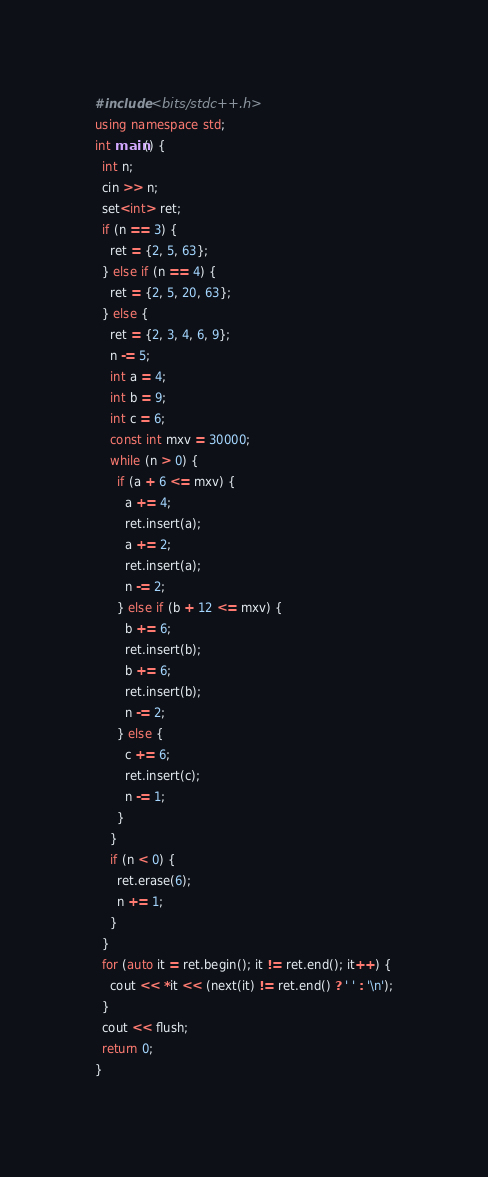Convert code to text. <code><loc_0><loc_0><loc_500><loc_500><_C++_>#include <bits/stdc++.h>
using namespace std;
int main() {
  int n;
  cin >> n;
  set<int> ret;
  if (n == 3) {
    ret = {2, 5, 63};
  } else if (n == 4) {
    ret = {2, 5, 20, 63};
  } else {
    ret = {2, 3, 4, 6, 9};
    n -= 5;
    int a = 4;
    int b = 9;
    int c = 6;
    const int mxv = 30000;
    while (n > 0) {
      if (a + 6 <= mxv) {
        a += 4;
        ret.insert(a);
        a += 2;
        ret.insert(a);
        n -= 2;
      } else if (b + 12 <= mxv) {
        b += 6;
        ret.insert(b);
        b += 6;
        ret.insert(b);
        n -= 2;
      } else {
        c += 6;
        ret.insert(c);
        n -= 1;
      }
    }
    if (n < 0) {
      ret.erase(6);
      n += 1;
    }
  }
  for (auto it = ret.begin(); it != ret.end(); it++) {
    cout << *it << (next(it) != ret.end() ? ' ' : '\n');
  }
  cout << flush;
  return 0;
}</code> 